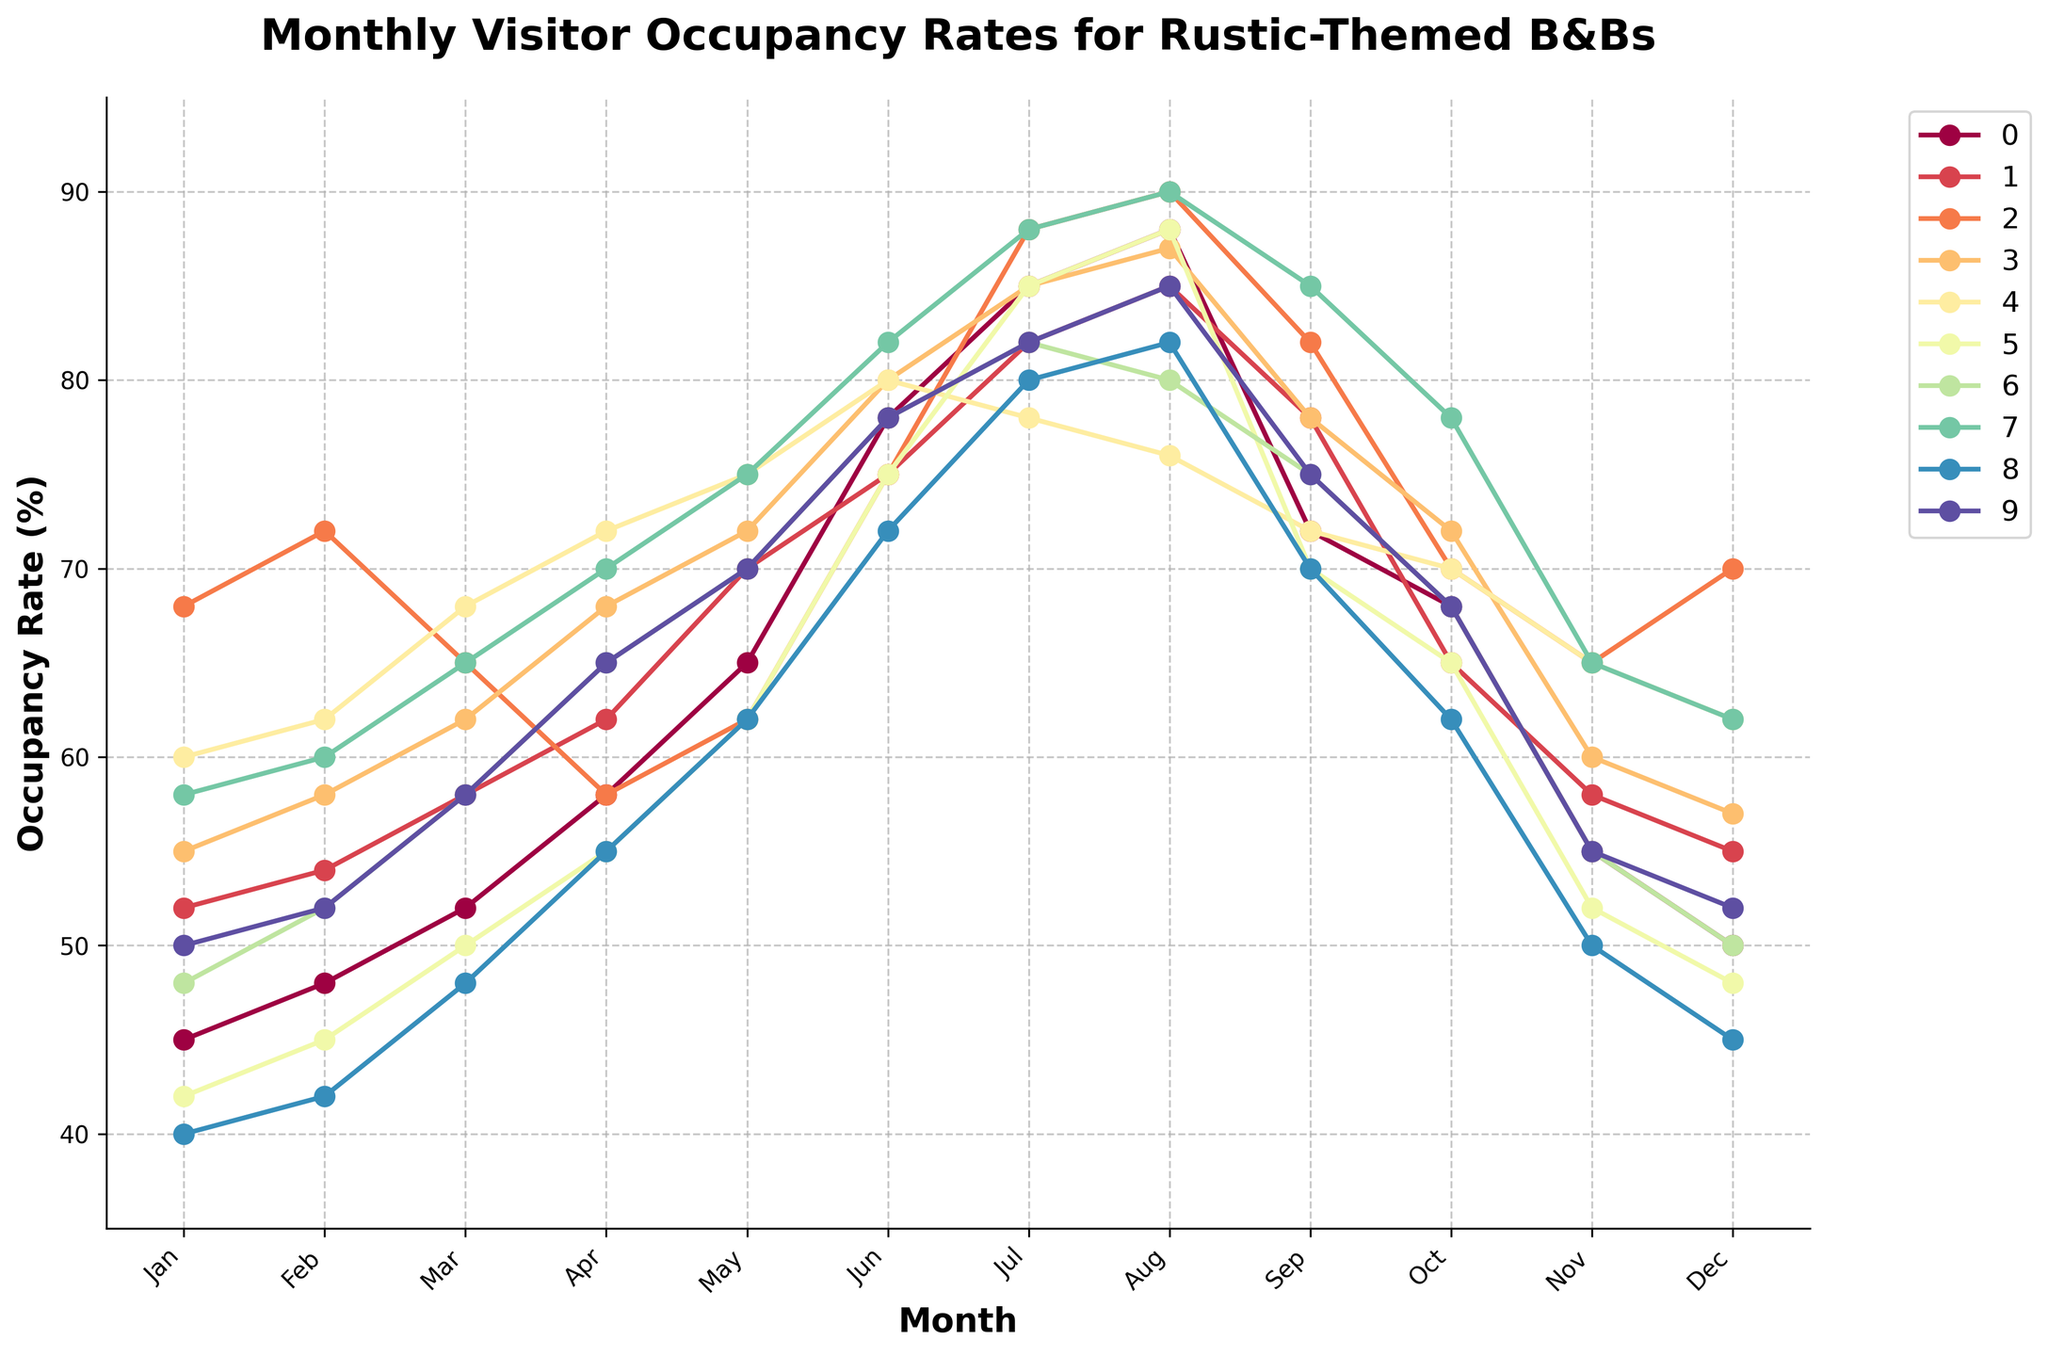Which region has the highest occupancy rate in July? Identify the lines representing July on the x-axis and find the line that reaches the highest point. Verify that the Rocky Mountains have the highest occupancy rate.
Answer: Rocky Mountains Which month has the lowest occupancy rate for the Upper Midwest? Look along the Upper Midwest line and identify the lowest point along the x-axis to find the corresponding month.
Answer: January Is the occupancy rate generally higher in summer (June, July, August) compared to winter (December, January, February) for Northern California? Compare the trend lines for Northern California in the summer months (Jun, Jul, Aug) and winter months (Dec, Jan, Feb). The summer months have consistently higher rates.
Answer: Yes What is the difference in occupancy rates between February and November in the Pacific Northwest? Find the points for February and November in the Pacific Northwest line. Calculate the difference (November rate minus February rate).
Answer: 4% Which region shows the most significant increase in occupancy rate from May to June? Examine the slopes between May and June for all the lines and identify which one has the steepest positive slope. The Adirondacks line shows the steepest increase.
Answer: Adirondacks Between Texas Hill Country and Appalachian Mountains, which region has a higher occupancy rate in March? Locate the points for March for both Texas Hill Country and Appalachian Mountains lines. Compare the two values and determine which one is higher.
Answer: Texas Hill Country What is the average occupancy rate for New England from January to June? Sum the occupancy rates from January to June for New England and divide by the number of months (6): (45+48+52+58+65+78) / 6.
Answer: 57.67% Which two regions have equal occupancy rates in December? Compare the December data points along the y-axis for all regions and find those that match. Upper Midwest and Adirondacks both have a rate of 48.
Answer: Upper Midwest and Adirondacks During which month does the Rocky Mountains region's occupancy rate peak? Examine the Rocky Mountains line and find the month corresponding to the highest point on the line.
Answer: August How does the occupancy rate in August for Ozarks compare with the rate in September for New England? Locate the August point for Ozarks and the September point for New England. Compare the two values. August (Ozarks) = 80, September (New England) = 72. Therefore, Ozarks is higher.
Answer: Ozarks is higher 